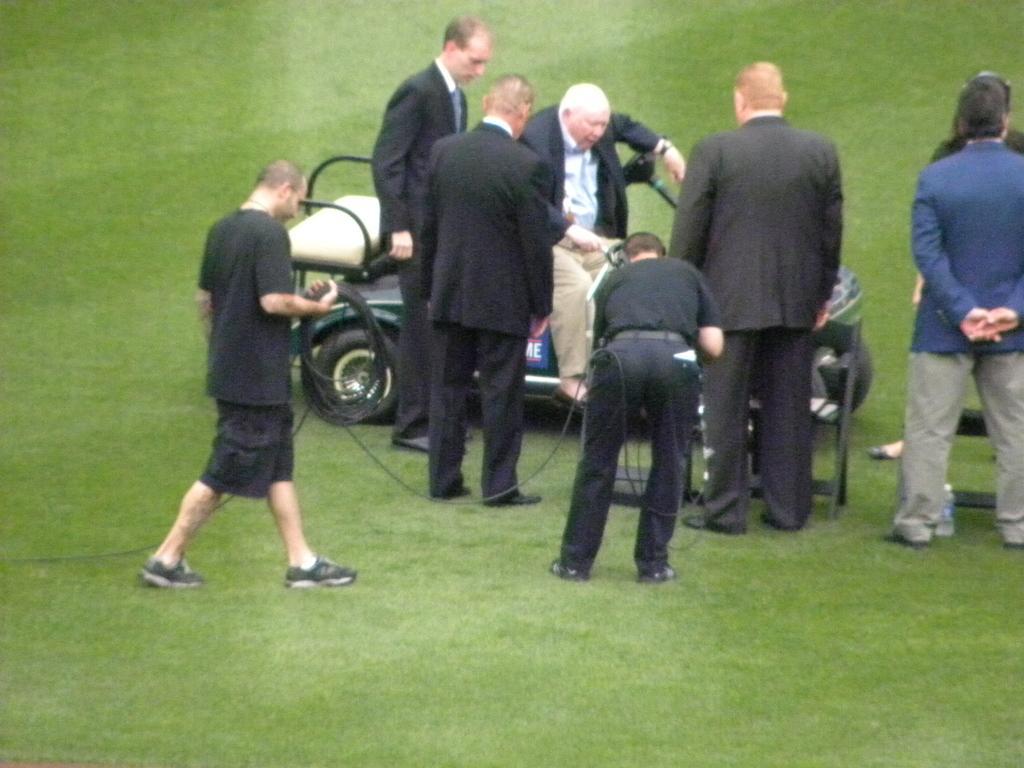Describe this image in one or two sentences. It is a garden, a man is sitting on a vehicle around him there are few other people standing,the person who is sitting on the vehicle is wearing a black coat. 